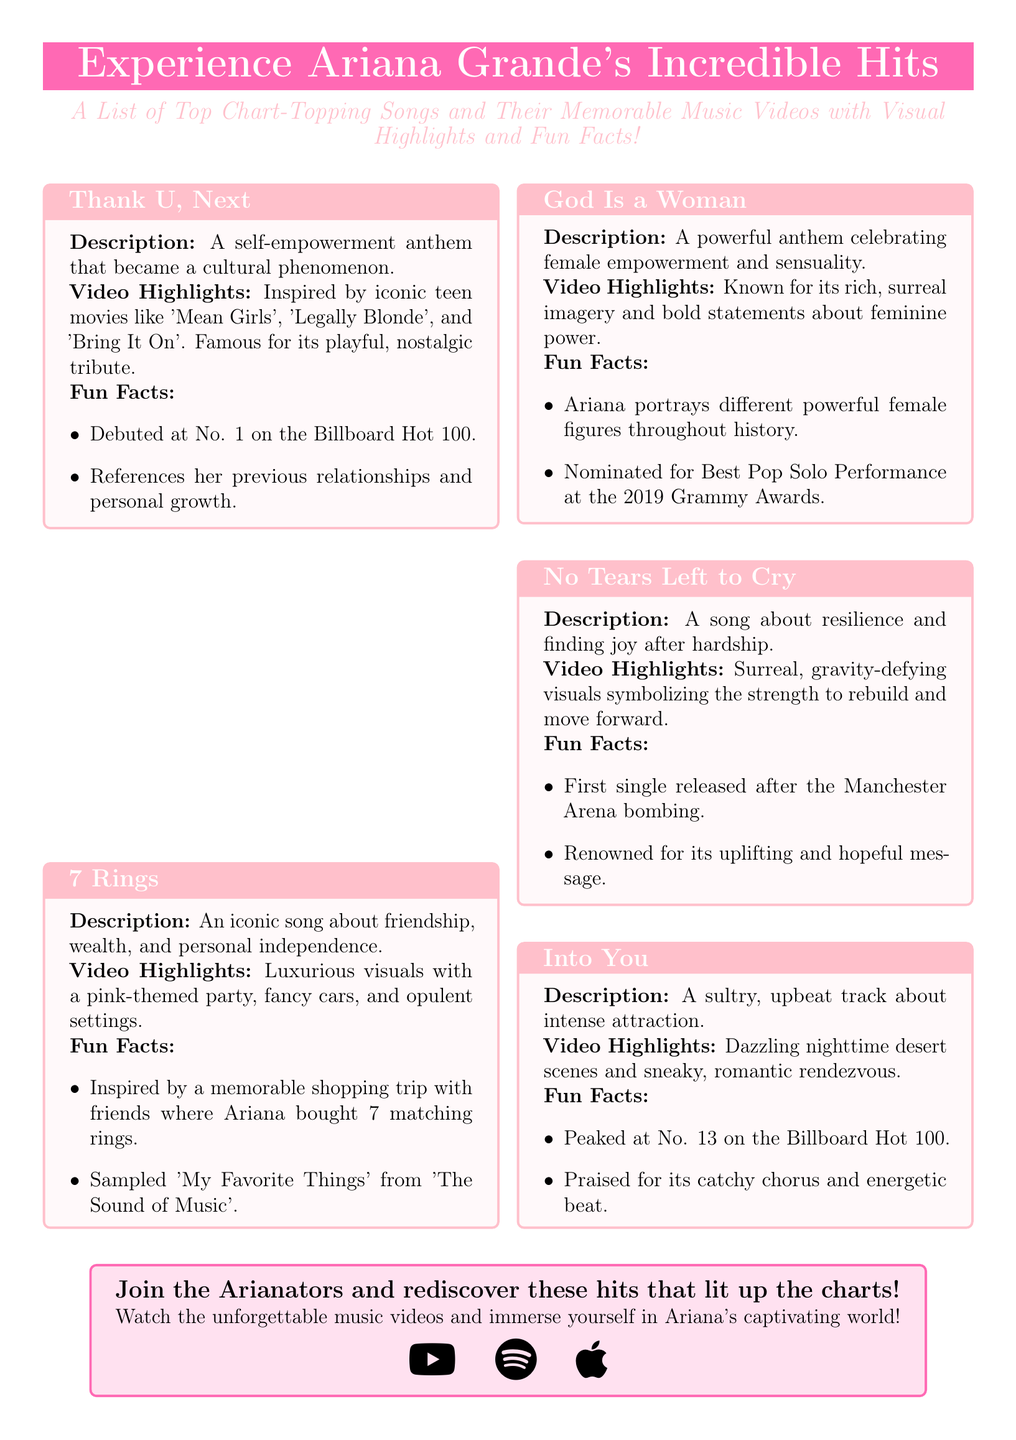What is the title of the flyer? The title of the flyer is prominently displayed and is "Experience Ariana Grande's Incredible Hits".
Answer: Experience Ariana Grande's Incredible Hits How many songs are listed in the document? The document lists five top chart-topping songs.
Answer: 5 What is the first song mentioned? The first song mentioned in the flyer is "Thank U, Next".
Answer: Thank U, Next Which song was released first after the Manchester Arena bombing? This specific event is associated with the song that carries a significant message about resilience, which is "No Tears Left to Cry".
Answer: No Tears Left to Cry What is a memorable theme from the song "7 Rings"? This song is about friendship, wealth, and personal independence.
Answer: Friendship, wealth, and personal independence How did "God Is a Woman" celebrate femininity? The song is described as a powerful anthem celebrating female empowerment and sensuality.
Answer: Female empowerment and sensuality What notable element is featured in the video for "No Tears Left to Cry"? The video is known for surreal, gravity-defying visuals symbolizing resilience.
Answer: Surreal, gravity-defying visuals What is a fun fact about the song "Into You"? A fun fact about this song is that it peaked at No. 13 on the Billboard Hot 100.
Answer: Peaked at No. 13 on the Billboard Hot 100 What platforms are mentioned for exploring Ariana's music? The flyer includes icons for various platforms, specifically YouTube, Spotify, and Apple Music.
Answer: YouTube, Spotify, Apple Music 